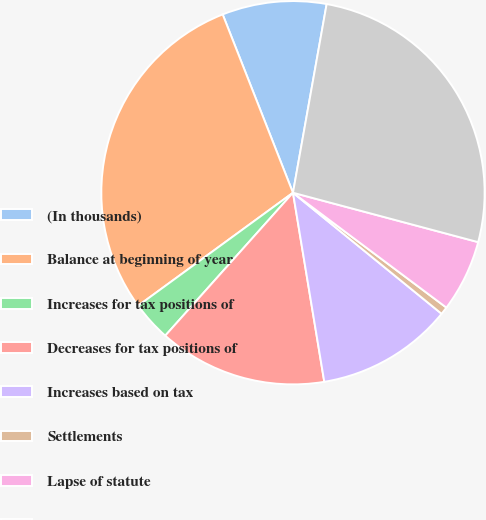Convert chart to OTSL. <chart><loc_0><loc_0><loc_500><loc_500><pie_chart><fcel>(In thousands)<fcel>Balance at beginning of year<fcel>Increases for tax positions of<fcel>Decreases for tax positions of<fcel>Increases based on tax<fcel>Settlements<fcel>Lapse of statute<fcel>Balance at end of year<nl><fcel>8.79%<fcel>29.06%<fcel>3.36%<fcel>14.22%<fcel>11.51%<fcel>0.65%<fcel>6.08%<fcel>26.34%<nl></chart> 